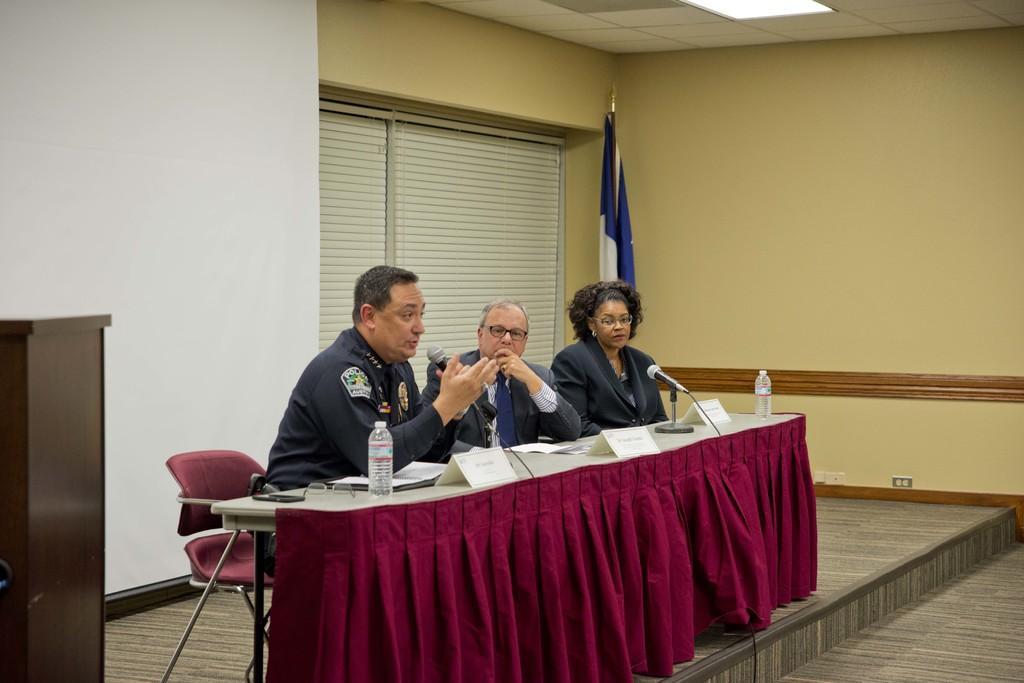How would you summarize this image in a sentence or two? The person wearing police uniform is sitting and speaking in front of a mic and there are two other persons sitting beside him and there is a flag in the background. 